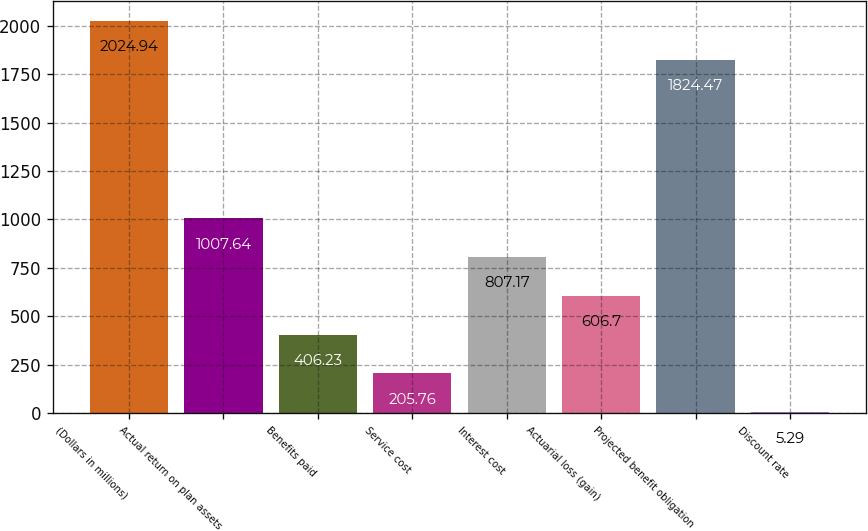Convert chart. <chart><loc_0><loc_0><loc_500><loc_500><bar_chart><fcel>(Dollars in millions)<fcel>Actual return on plan assets<fcel>Benefits paid<fcel>Service cost<fcel>Interest cost<fcel>Actuarial loss (gain)<fcel>Projected benefit obligation<fcel>Discount rate<nl><fcel>2024.94<fcel>1007.64<fcel>406.23<fcel>205.76<fcel>807.17<fcel>606.7<fcel>1824.47<fcel>5.29<nl></chart> 